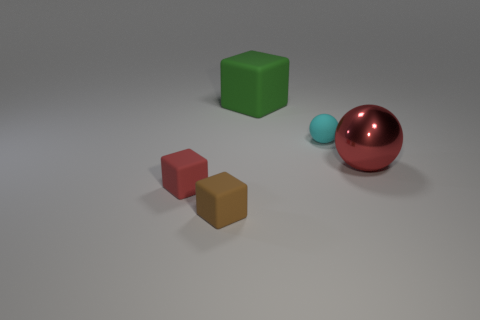Add 2 cyan rubber objects. How many objects exist? 7 Subtract all green blocks. How many blocks are left? 2 Subtract all balls. How many objects are left? 3 Subtract all small cyan balls. Subtract all big green cubes. How many objects are left? 3 Add 5 brown rubber things. How many brown rubber things are left? 6 Add 4 large metal balls. How many large metal balls exist? 5 Subtract all cyan balls. How many balls are left? 1 Subtract 0 purple cylinders. How many objects are left? 5 Subtract all gray spheres. Subtract all blue cylinders. How many spheres are left? 2 Subtract all purple balls. How many brown blocks are left? 1 